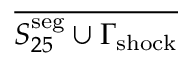<formula> <loc_0><loc_0><loc_500><loc_500>\overline { { S _ { 2 5 } ^ { s e g } \cup \Gamma _ { s h o c k } } }</formula> 